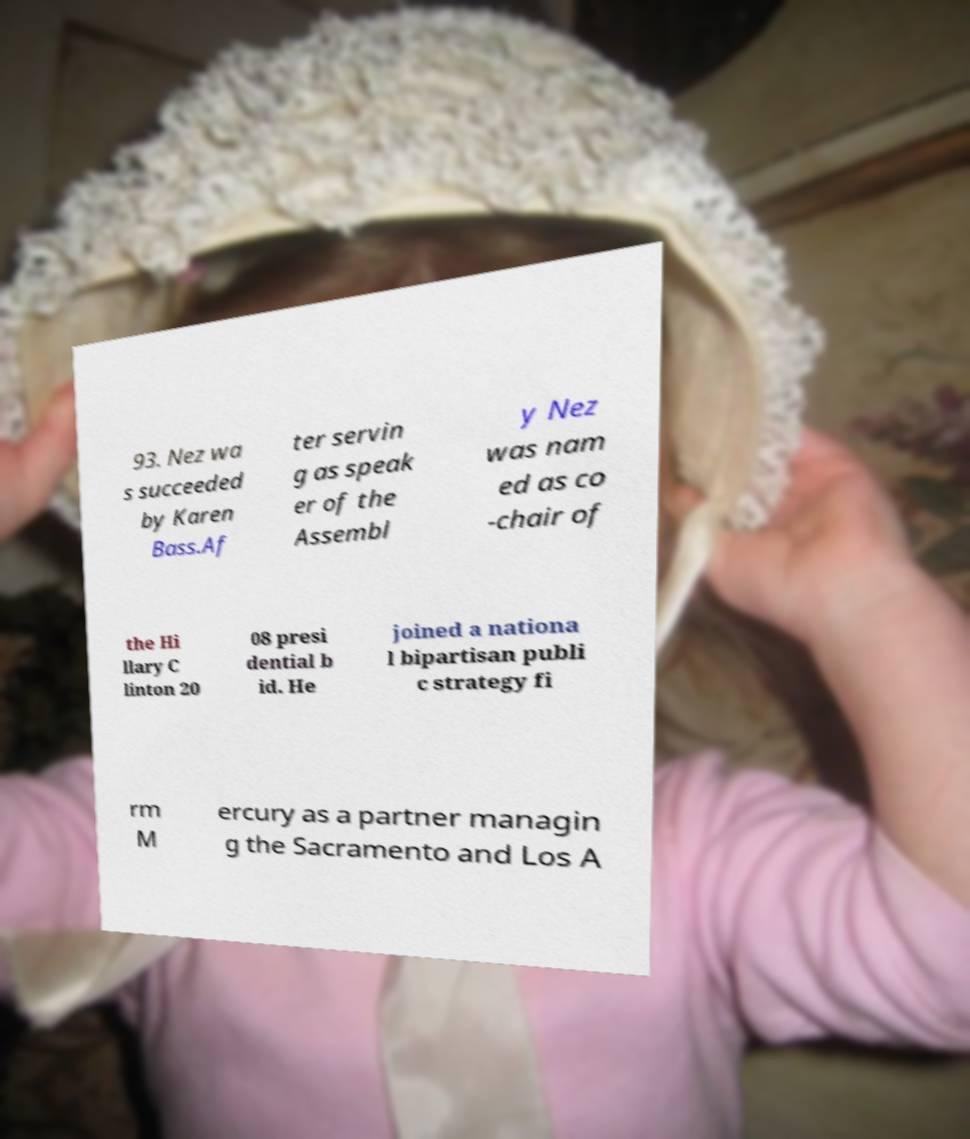Could you extract and type out the text from this image? 93. Nez wa s succeeded by Karen Bass.Af ter servin g as speak er of the Assembl y Nez was nam ed as co -chair of the Hi llary C linton 20 08 presi dential b id. He joined a nationa l bipartisan publi c strategy fi rm M ercury as a partner managin g the Sacramento and Los A 